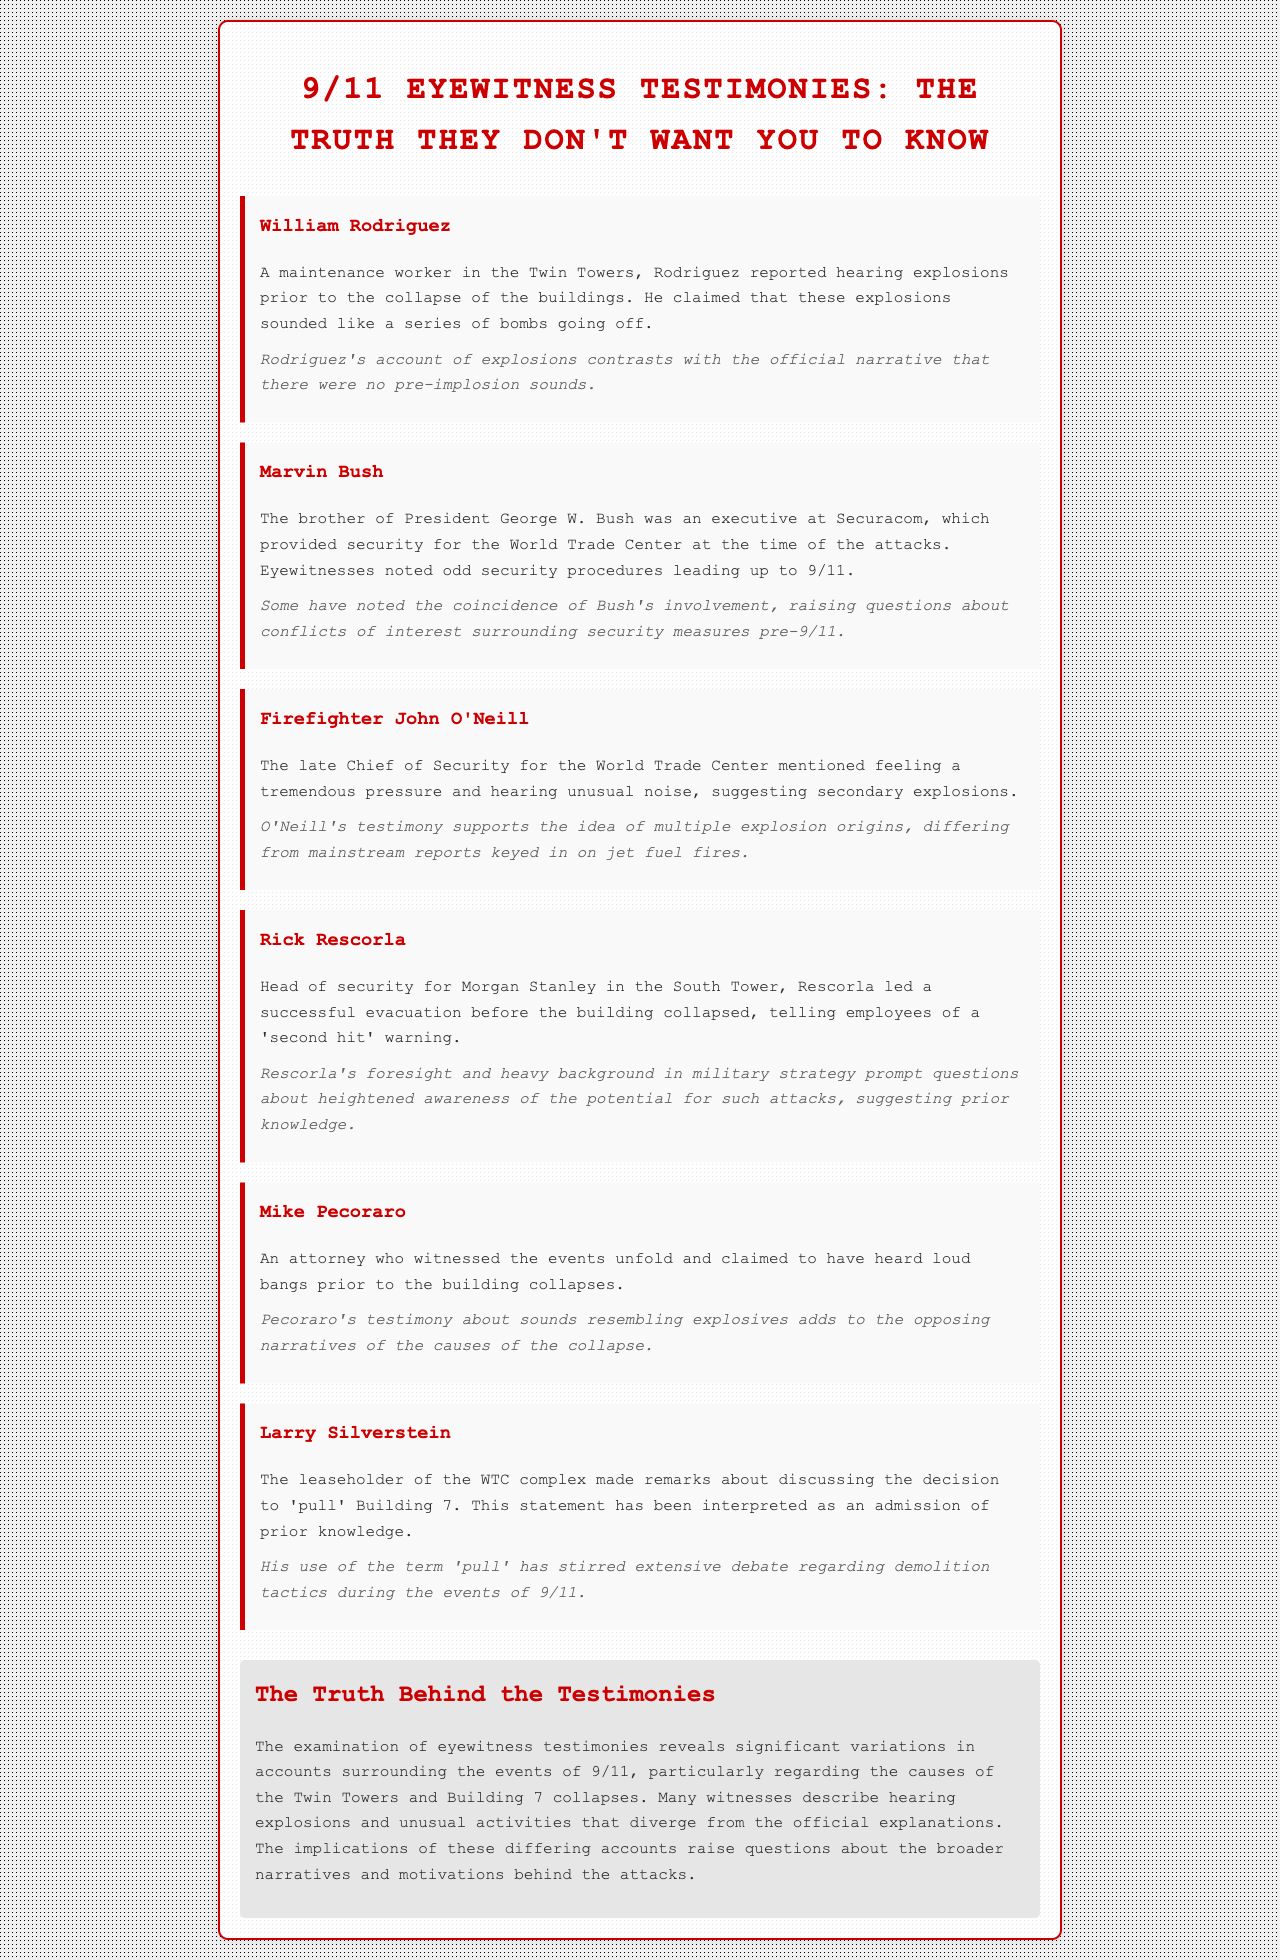What did William Rodriguez hear prior to the collapse? Rodriguez reported hearing explosions prior to the collapse of the buildings.
Answer: explosions Who is Marvin Bush? Marvin Bush is the brother of President George W. Bush and was an executive at Securacom.
Answer: Marvin Bush What did Chief John O'Neill mention he felt? Chief John O'Neill mentioned feeling tremendous pressure and hearing unusual noise.
Answer: tremendous pressure What was Rick Rescorla's role on 9/11? Rick Rescorla was the head of security for Morgan Stanley in the South Tower.
Answer: head of security What did Mike Pecoraro claim to have heard? Mike Pecoraro claimed to have heard loud bangs prior to the building collapses.
Answer: loud bangs What is the significance of Larry Silverstein's remarks? Larry Silverstein’s remarks have been interpreted as an admission of prior knowledge regarding the decision to 'pull' Building 7.
Answer: admission of prior knowledge How do the eyewitness testimonies generally diverge? The eyewitness testimonies diverge regarding the causes of the Twin Towers and Building 7 collapses.
Answer: causes of the collapses What does the summary suggest about the witness accounts? The summary suggests that witness accounts reveal significant variations surrounding the events of 9/11.
Answer: significant variations 